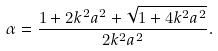<formula> <loc_0><loc_0><loc_500><loc_500>\alpha = \frac { 1 + 2 k ^ { 2 } a ^ { 2 } + \sqrt { 1 + 4 k ^ { 2 } a ^ { 2 } } } { 2 k ^ { 2 } a ^ { 2 } } .</formula> 